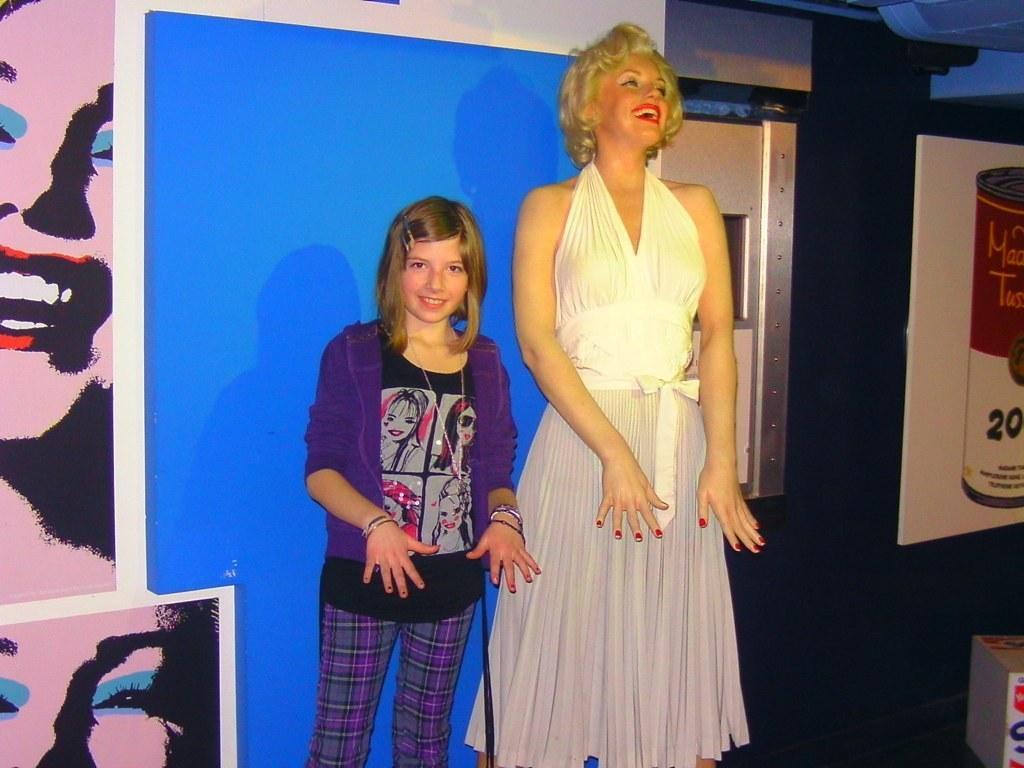Can you describe this image briefly? In the middle a girl is standing by showing her hands, she wore a purple color sweater beside her a beautiful woman is standing. She wore a white color dress and she is smiling. 